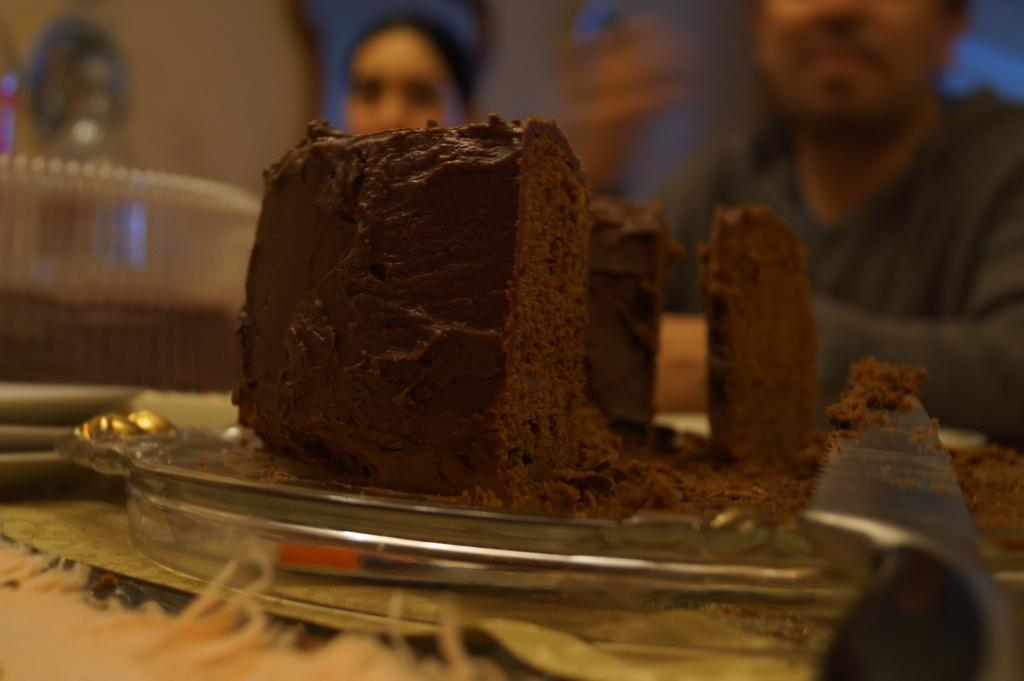What is on the plate in the image? There is a cake on the plate. What is placed next to the cake on the plate? There is a knife on the plate. Who is present in the image besides the cake and plate? There are two people behind the cake. What can be seen in the background of the image? There are some blurred things in the background. What part of the brain can be seen in the image? There is no brain visible in the image; it features a plate with a cake, a knife, and two people behind the cake. How does the cake act in the image? The cake does not act in the image; it is a stationary object on the plate. 